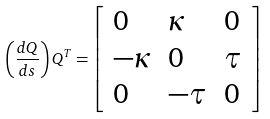<formula> <loc_0><loc_0><loc_500><loc_500>\left ( { \frac { d Q } { d s } } \right ) Q ^ { T } = \left [ { \begin{array} { l l l } { 0 } & { \kappa } & { 0 } \\ { - \kappa } & { 0 } & { \tau } \\ { 0 } & { - \tau } & { 0 } \end{array} } \right ]</formula> 